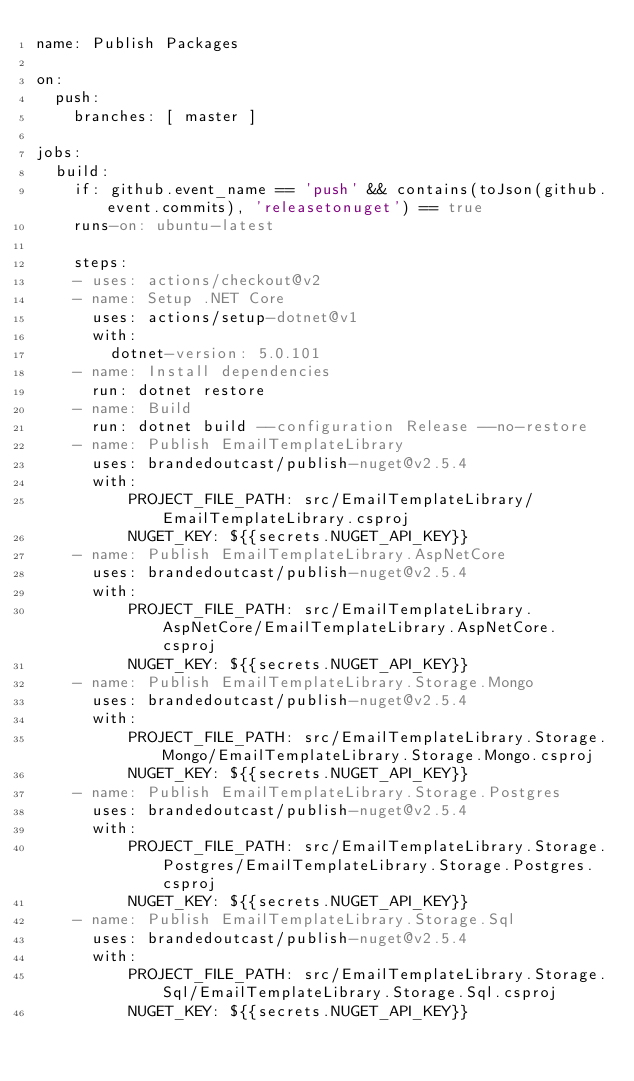<code> <loc_0><loc_0><loc_500><loc_500><_YAML_>name: Publish Packages

on:
  push:
    branches: [ master ] 

jobs:
  build:
    if: github.event_name == 'push' && contains(toJson(github.event.commits), 'releasetonuget') == true
    runs-on: ubuntu-latest

    steps:
    - uses: actions/checkout@v2
    - name: Setup .NET Core
      uses: actions/setup-dotnet@v1
      with:
        dotnet-version: 5.0.101
    - name: Install dependencies
      run: dotnet restore
    - name: Build
      run: dotnet build --configuration Release --no-restore
    - name: Publish EmailTemplateLibrary
      uses: brandedoutcast/publish-nuget@v2.5.4
      with:
          PROJECT_FILE_PATH: src/EmailTemplateLibrary/EmailTemplateLibrary.csproj
          NUGET_KEY: ${{secrets.NUGET_API_KEY}}
    - name: Publish EmailTemplateLibrary.AspNetCore
      uses: brandedoutcast/publish-nuget@v2.5.4
      with:
          PROJECT_FILE_PATH: src/EmailTemplateLibrary.AspNetCore/EmailTemplateLibrary.AspNetCore.csproj
          NUGET_KEY: ${{secrets.NUGET_API_KEY}}
    - name: Publish EmailTemplateLibrary.Storage.Mongo
      uses: brandedoutcast/publish-nuget@v2.5.4
      with:
          PROJECT_FILE_PATH: src/EmailTemplateLibrary.Storage.Mongo/EmailTemplateLibrary.Storage.Mongo.csproj
          NUGET_KEY: ${{secrets.NUGET_API_KEY}}
    - name: Publish EmailTemplateLibrary.Storage.Postgres
      uses: brandedoutcast/publish-nuget@v2.5.4
      with:
          PROJECT_FILE_PATH: src/EmailTemplateLibrary.Storage.Postgres/EmailTemplateLibrary.Storage.Postgres.csproj
          NUGET_KEY: ${{secrets.NUGET_API_KEY}}
    - name: Publish EmailTemplateLibrary.Storage.Sql
      uses: brandedoutcast/publish-nuget@v2.5.4
      with:
          PROJECT_FILE_PATH: src/EmailTemplateLibrary.Storage.Sql/EmailTemplateLibrary.Storage.Sql.csproj
          NUGET_KEY: ${{secrets.NUGET_API_KEY}}
</code> 